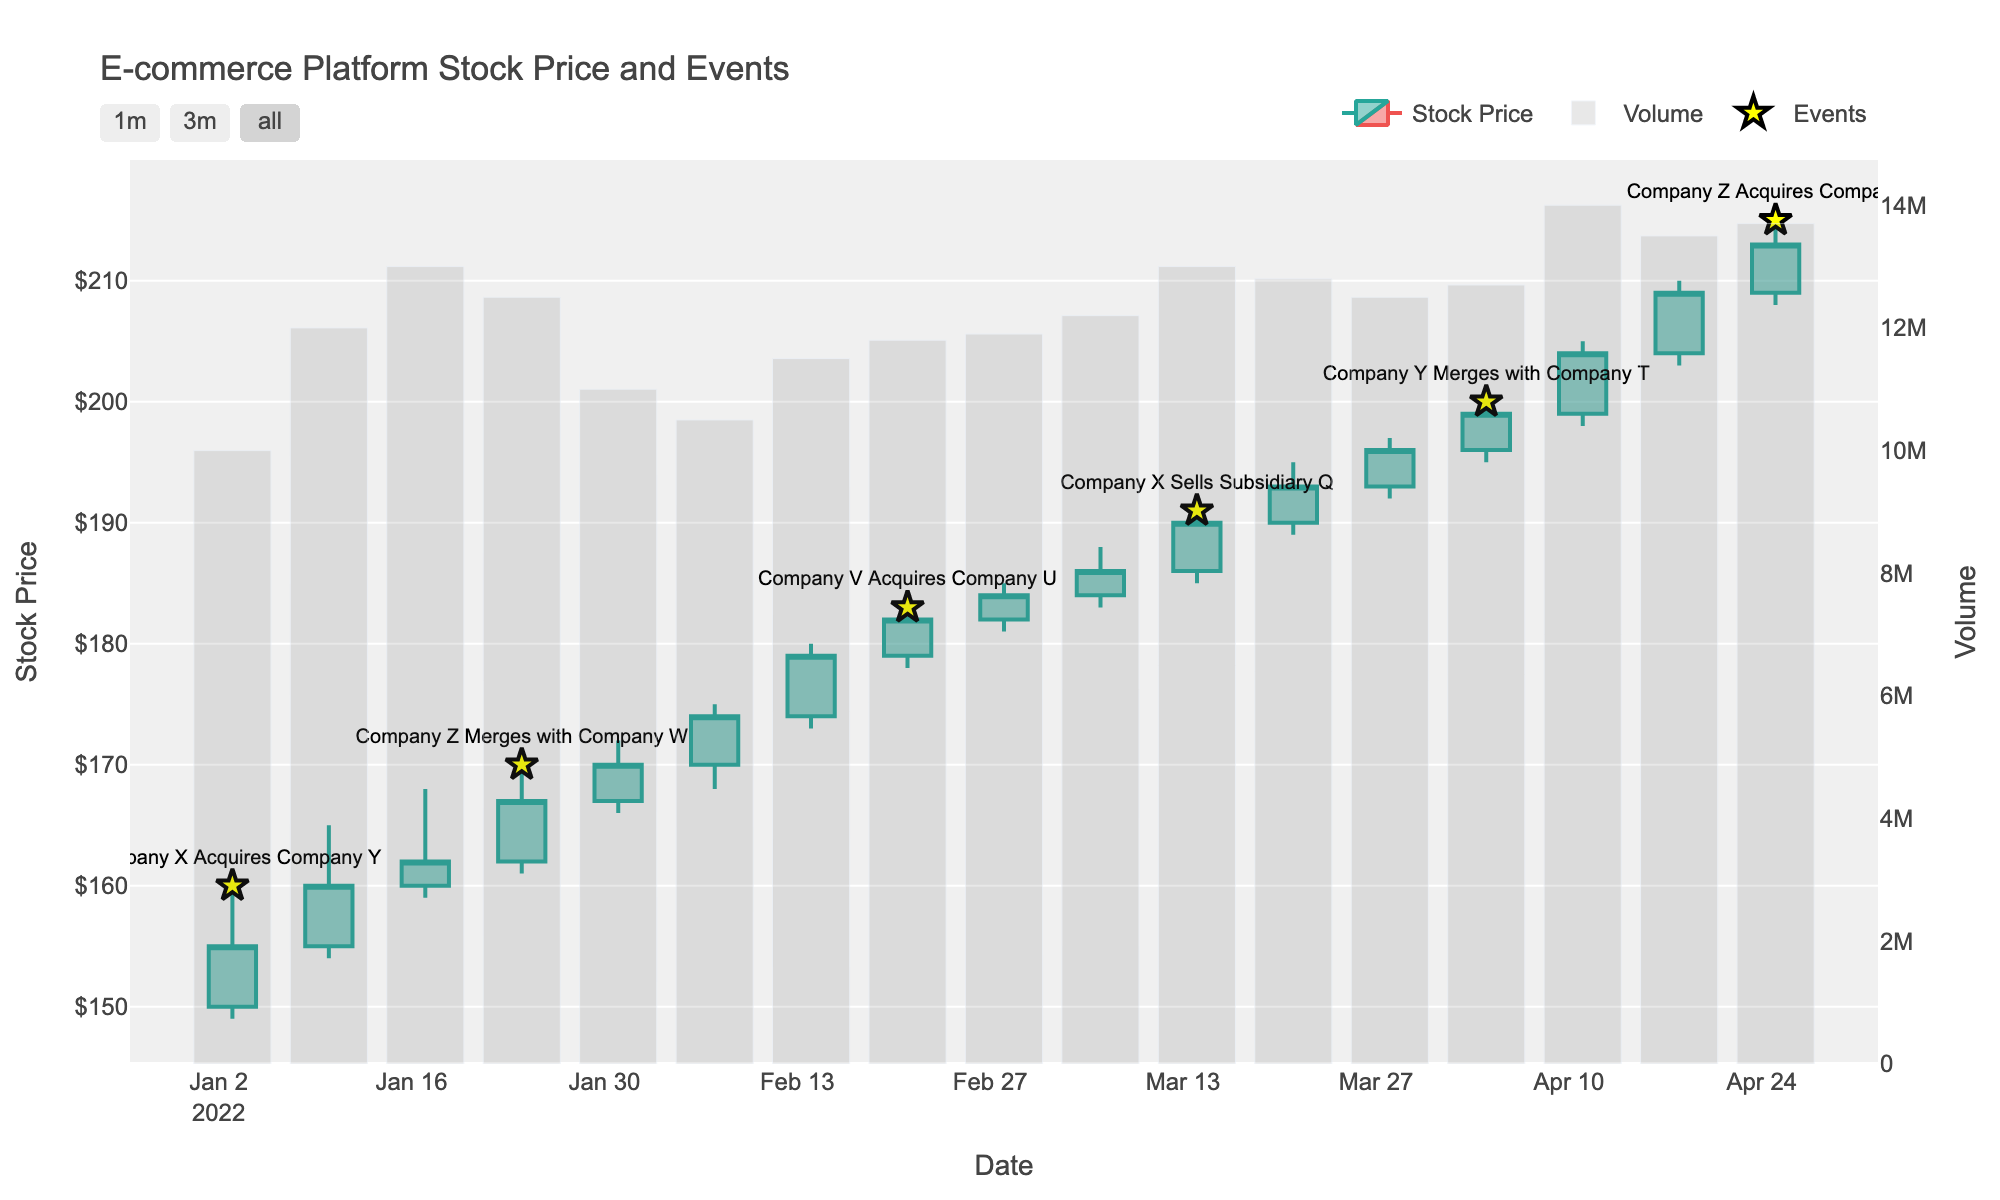What is the title of the figure? The title is usually located at the top of a figure. You can read the title directly from the visual information provided.
Answer: E-commerce Platform Stock Price and Events How many events are marked on the chart? You can count the number of event markers (star symbols) shown in the figure.
Answer: 5 What is the highest stock price recorded and during which event did it occur? Identify the highest point on the candlestick chart where an event marker is located. Look for the text associated with that marker for the event.
Answer: $215.00 during "Company Z Acquires Company R" Which event marked the largest increase in stock price within a week? Calculate the difference in closing prices for the weeks with events and find the event with the largest increase.
Answer: Company X Acquires Company Y How does the stock volume on the day "Company Z Merges with Company W" compare to the volume on the previous day? Compare the volume bar heights of the date "Company Z Merges with Company W" and the previous date visually.
Answer: The volume increased What is the approximate slope of the stock price trend from the first event to the last event? Draw an imaginary line connecting the closing prices from the first event to the last event and estimate the slope.
Answer: Positive slope What was the stock price trend after the "Company X Sells Subsidiary Q" event? Observe the candlestick movements immediately after the event date and describe the trend (up/down/steady).
Answer: Upward Which event is correlated with the highest trading volume? Identify the tallest volume bar and locate the event marker nearest to that date.
Answer: Company Y Merges with Company T How long after "Company X Acquires Company Y" did the stock reach its first significant peak? Identify the date of the first significant peak after the given event, then calculate the time difference.
Answer: 21 days Were there any notable changes in stock price stability before and after the "Company V Acquires Company U" event? Compare the consistency and size of candlesticks before and after the event to assess stability changes.
Answer: More stable before the event 